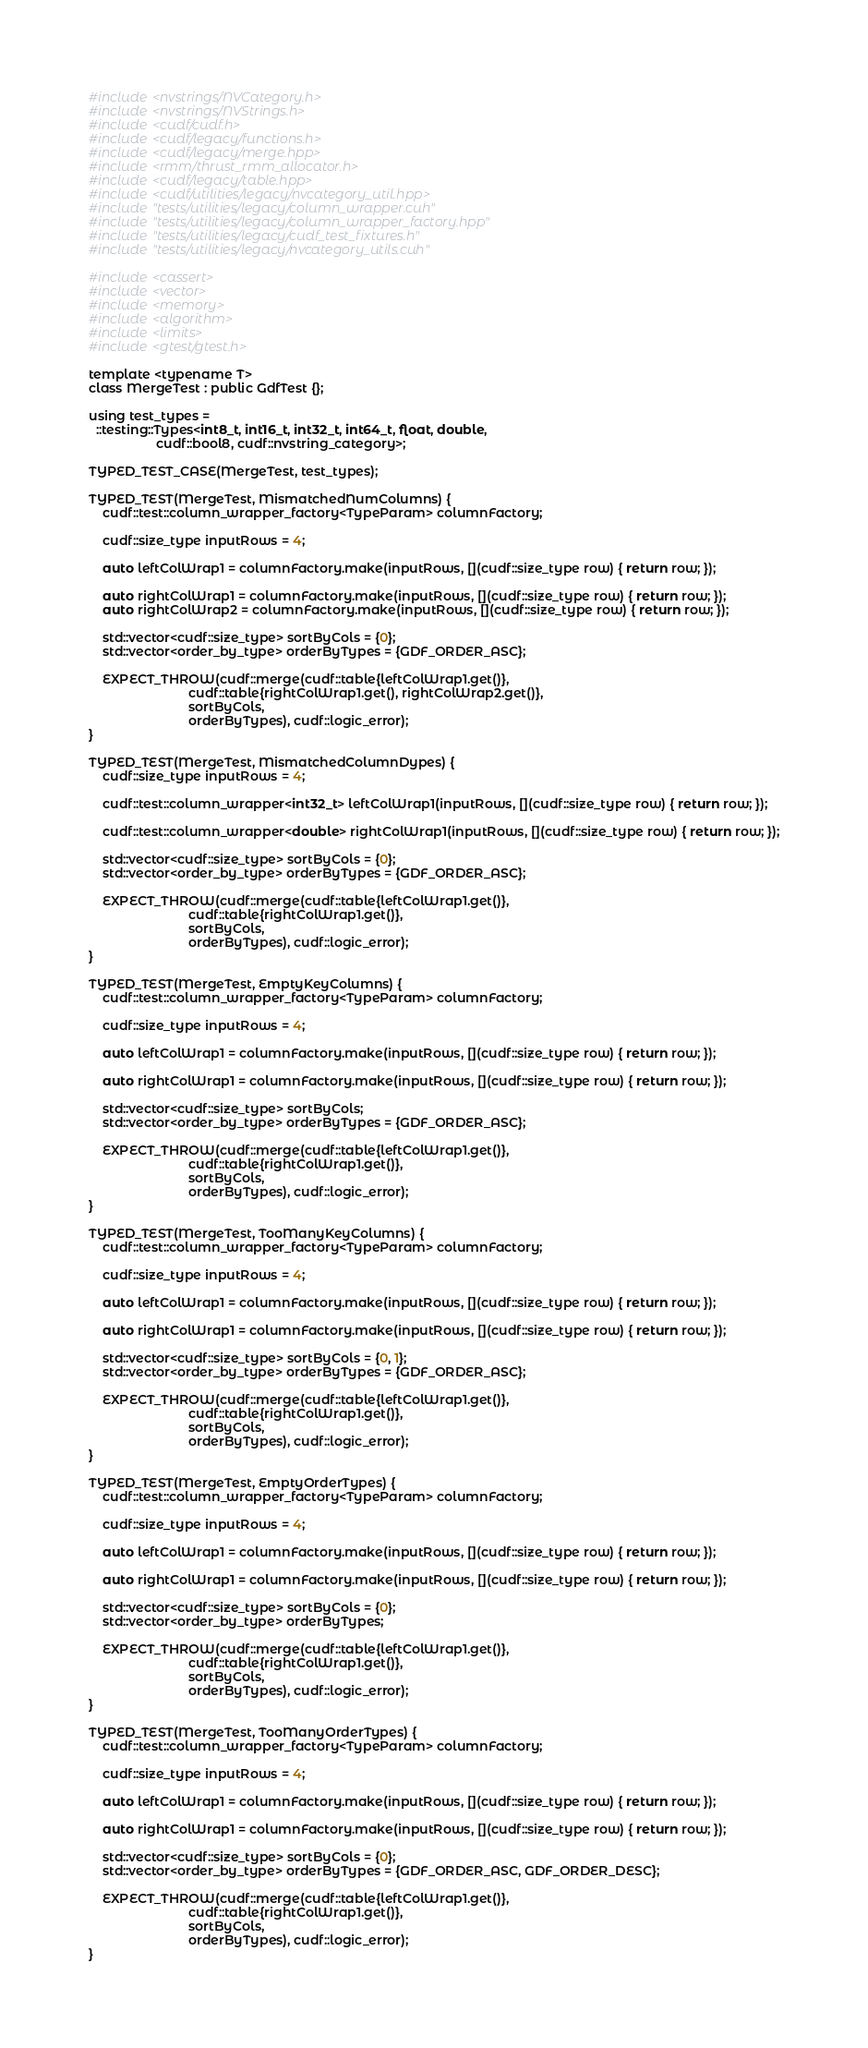Convert code to text. <code><loc_0><loc_0><loc_500><loc_500><_Cuda_>#include <nvstrings/NVCategory.h>
#include <nvstrings/NVStrings.h>
#include <cudf/cudf.h>
#include <cudf/legacy/functions.h>
#include <cudf/legacy/merge.hpp>
#include <rmm/thrust_rmm_allocator.h>
#include <cudf/legacy/table.hpp>
#include <cudf/utilities/legacy/nvcategory_util.hpp>
#include "tests/utilities/legacy/column_wrapper.cuh"
#include "tests/utilities/legacy/column_wrapper_factory.hpp"
#include "tests/utilities/legacy/cudf_test_fixtures.h"
#include "tests/utilities/legacy/nvcategory_utils.cuh"

#include <cassert>
#include <vector>
#include <memory>
#include <algorithm>
#include <limits>
#include <gtest/gtest.h>

template <typename T>
class MergeTest : public GdfTest {};

using test_types =
  ::testing::Types<int8_t, int16_t, int32_t, int64_t, float, double,
                   cudf::bool8, cudf::nvstring_category>;

TYPED_TEST_CASE(MergeTest, test_types);

TYPED_TEST(MergeTest, MismatchedNumColumns) {
    cudf::test::column_wrapper_factory<TypeParam> columnFactory;

    cudf::size_type inputRows = 4;

    auto leftColWrap1 = columnFactory.make(inputRows, [](cudf::size_type row) { return row; });

    auto rightColWrap1 = columnFactory.make(inputRows, [](cudf::size_type row) { return row; });
    auto rightColWrap2 = columnFactory.make(inputRows, [](cudf::size_type row) { return row; });

    std::vector<cudf::size_type> sortByCols = {0};
    std::vector<order_by_type> orderByTypes = {GDF_ORDER_ASC};

    EXPECT_THROW(cudf::merge(cudf::table{leftColWrap1.get()},
                            cudf::table{rightColWrap1.get(), rightColWrap2.get()},
                            sortByCols,
                            orderByTypes), cudf::logic_error);
}

TYPED_TEST(MergeTest, MismatchedColumnDypes) {
    cudf::size_type inputRows = 4;

    cudf::test::column_wrapper<int32_t> leftColWrap1(inputRows, [](cudf::size_type row) { return row; });

    cudf::test::column_wrapper<double> rightColWrap1(inputRows, [](cudf::size_type row) { return row; });

    std::vector<cudf::size_type> sortByCols = {0};
    std::vector<order_by_type> orderByTypes = {GDF_ORDER_ASC};

    EXPECT_THROW(cudf::merge(cudf::table{leftColWrap1.get()},
                            cudf::table{rightColWrap1.get()},
                            sortByCols,
                            orderByTypes), cudf::logic_error);
}

TYPED_TEST(MergeTest, EmptyKeyColumns) {
    cudf::test::column_wrapper_factory<TypeParam> columnFactory;

    cudf::size_type inputRows = 4;

    auto leftColWrap1 = columnFactory.make(inputRows, [](cudf::size_type row) { return row; });

    auto rightColWrap1 = columnFactory.make(inputRows, [](cudf::size_type row) { return row; });

    std::vector<cudf::size_type> sortByCols;
    std::vector<order_by_type> orderByTypes = {GDF_ORDER_ASC};

    EXPECT_THROW(cudf::merge(cudf::table{leftColWrap1.get()},
                            cudf::table{rightColWrap1.get()},
                            sortByCols,
                            orderByTypes), cudf::logic_error);
}

TYPED_TEST(MergeTest, TooManyKeyColumns) {
    cudf::test::column_wrapper_factory<TypeParam> columnFactory;

    cudf::size_type inputRows = 4;

    auto leftColWrap1 = columnFactory.make(inputRows, [](cudf::size_type row) { return row; });

    auto rightColWrap1 = columnFactory.make(inputRows, [](cudf::size_type row) { return row; });

    std::vector<cudf::size_type> sortByCols = {0, 1};
    std::vector<order_by_type> orderByTypes = {GDF_ORDER_ASC};

    EXPECT_THROW(cudf::merge(cudf::table{leftColWrap1.get()},
                            cudf::table{rightColWrap1.get()},
                            sortByCols,
                            orderByTypes), cudf::logic_error);
}

TYPED_TEST(MergeTest, EmptyOrderTypes) {
    cudf::test::column_wrapper_factory<TypeParam> columnFactory;

    cudf::size_type inputRows = 4;

    auto leftColWrap1 = columnFactory.make(inputRows, [](cudf::size_type row) { return row; });

    auto rightColWrap1 = columnFactory.make(inputRows, [](cudf::size_type row) { return row; });

    std::vector<cudf::size_type> sortByCols = {0};
    std::vector<order_by_type> orderByTypes;

    EXPECT_THROW(cudf::merge(cudf::table{leftColWrap1.get()},
                            cudf::table{rightColWrap1.get()},
                            sortByCols,
                            orderByTypes), cudf::logic_error);
}

TYPED_TEST(MergeTest, TooManyOrderTypes) {
    cudf::test::column_wrapper_factory<TypeParam> columnFactory;

    cudf::size_type inputRows = 4;

    auto leftColWrap1 = columnFactory.make(inputRows, [](cudf::size_type row) { return row; });

    auto rightColWrap1 = columnFactory.make(inputRows, [](cudf::size_type row) { return row; });

    std::vector<cudf::size_type> sortByCols = {0};
    std::vector<order_by_type> orderByTypes = {GDF_ORDER_ASC, GDF_ORDER_DESC};

    EXPECT_THROW(cudf::merge(cudf::table{leftColWrap1.get()},
                            cudf::table{rightColWrap1.get()},
                            sortByCols,
                            orderByTypes), cudf::logic_error);
}
</code> 